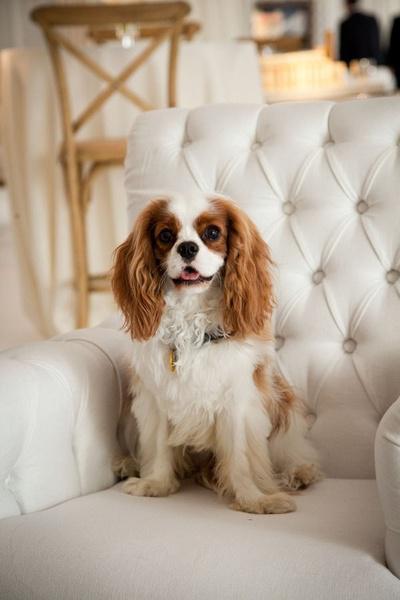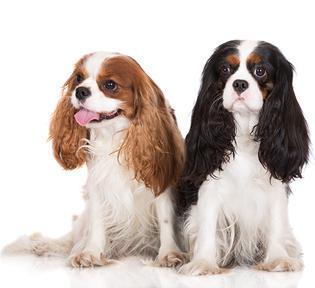The first image is the image on the left, the second image is the image on the right. For the images displayed, is the sentence "One image shows a nursing mother spaniel with several spotted puppies." factually correct? Answer yes or no. No. 